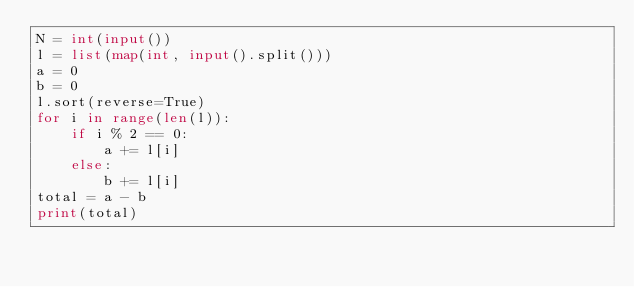Convert code to text. <code><loc_0><loc_0><loc_500><loc_500><_Python_>N = int(input())
l = list(map(int, input().split()))
a = 0
b = 0
l.sort(reverse=True)
for i in range(len(l)):
    if i % 2 == 0:
        a += l[i]
    else:
        b += l[i]
total = a - b
print(total)</code> 